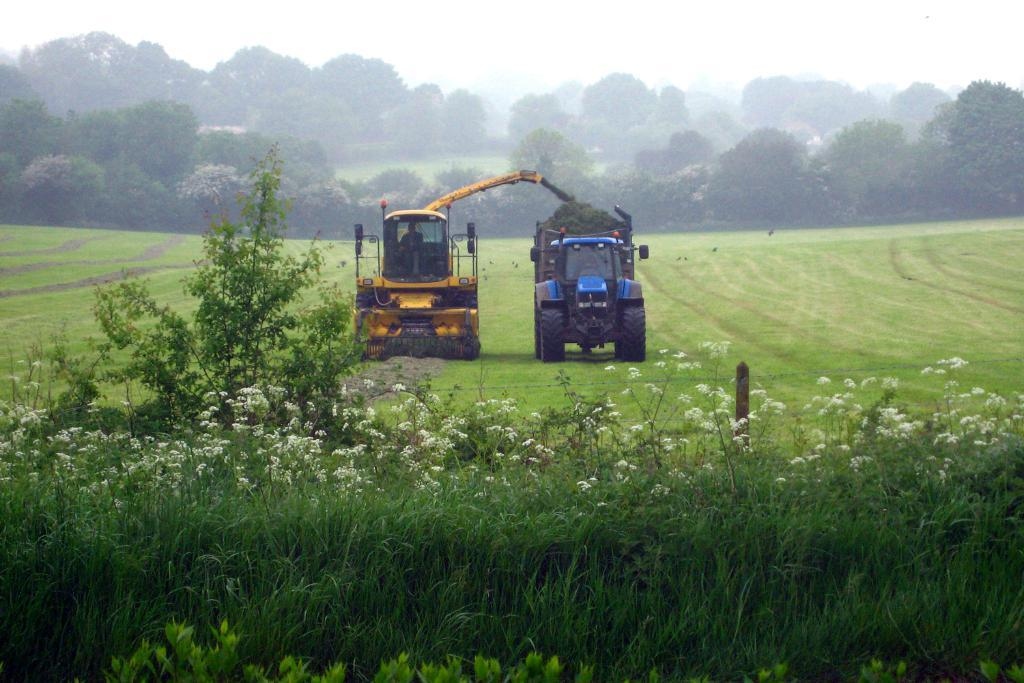How many vehicles are in the image? There are two vehicles in the image. What colors are the vehicles? One vehicle is blue, and the other is yellow. What can be seen in the background of the image? There is a sky, trees, plants, grass, and flowers visible in the background of the image. What type of sock is hanging from the blue vehicle in the image? There is no sock present in the image, and therefore no such item can be observed hanging from the blue vehicle. 